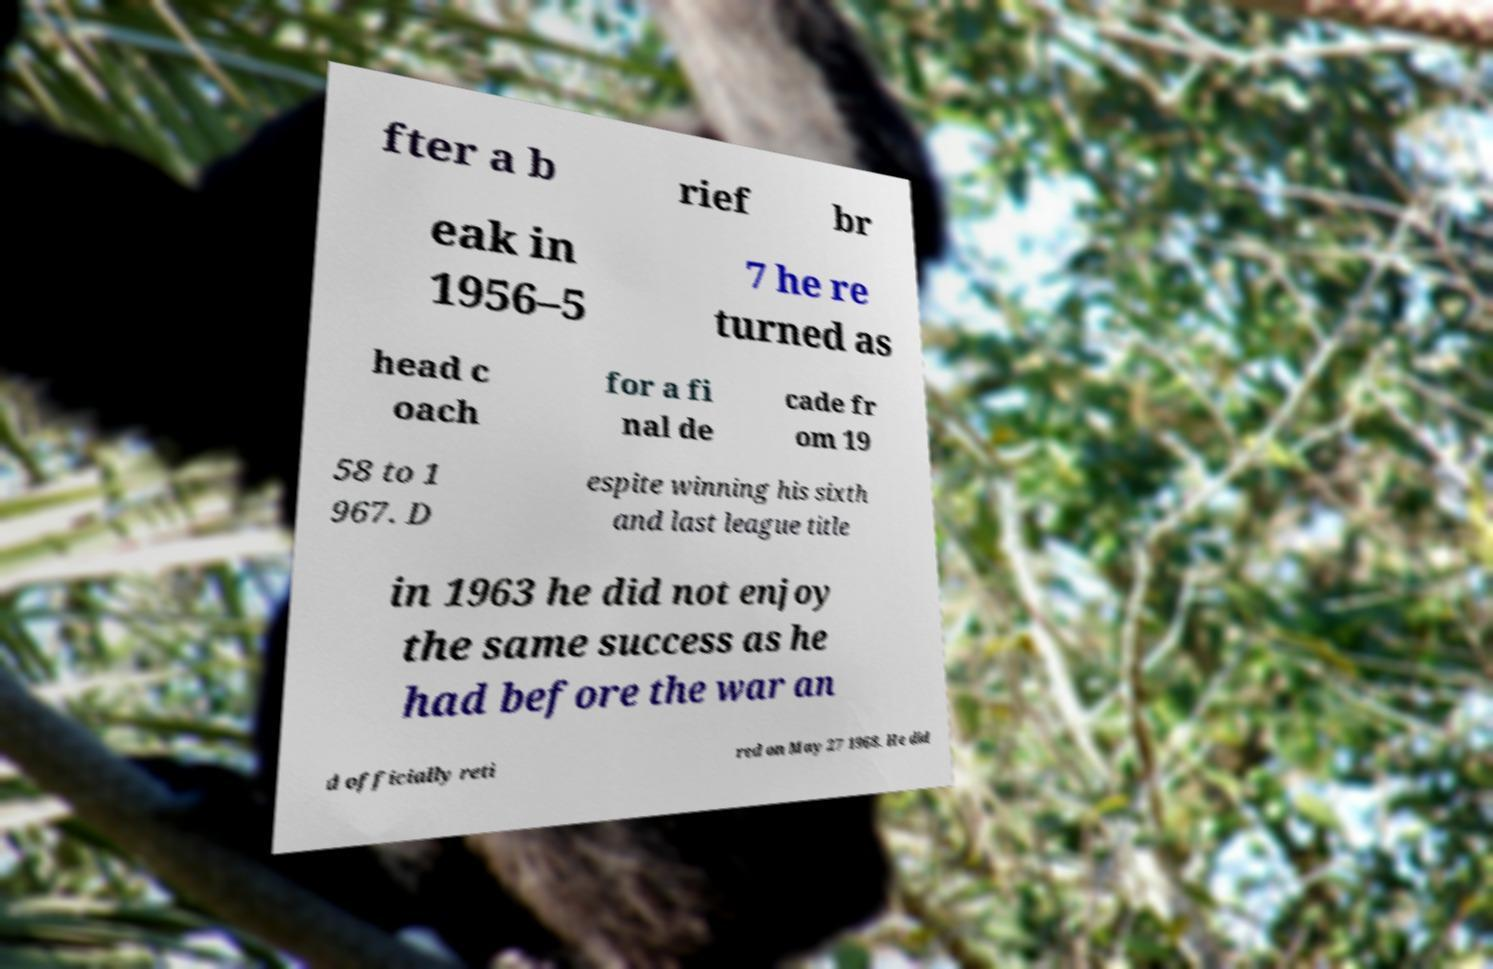Could you extract and type out the text from this image? fter a b rief br eak in 1956–5 7 he re turned as head c oach for a fi nal de cade fr om 19 58 to 1 967. D espite winning his sixth and last league title in 1963 he did not enjoy the same success as he had before the war an d officially reti red on May 27 1968. He did 